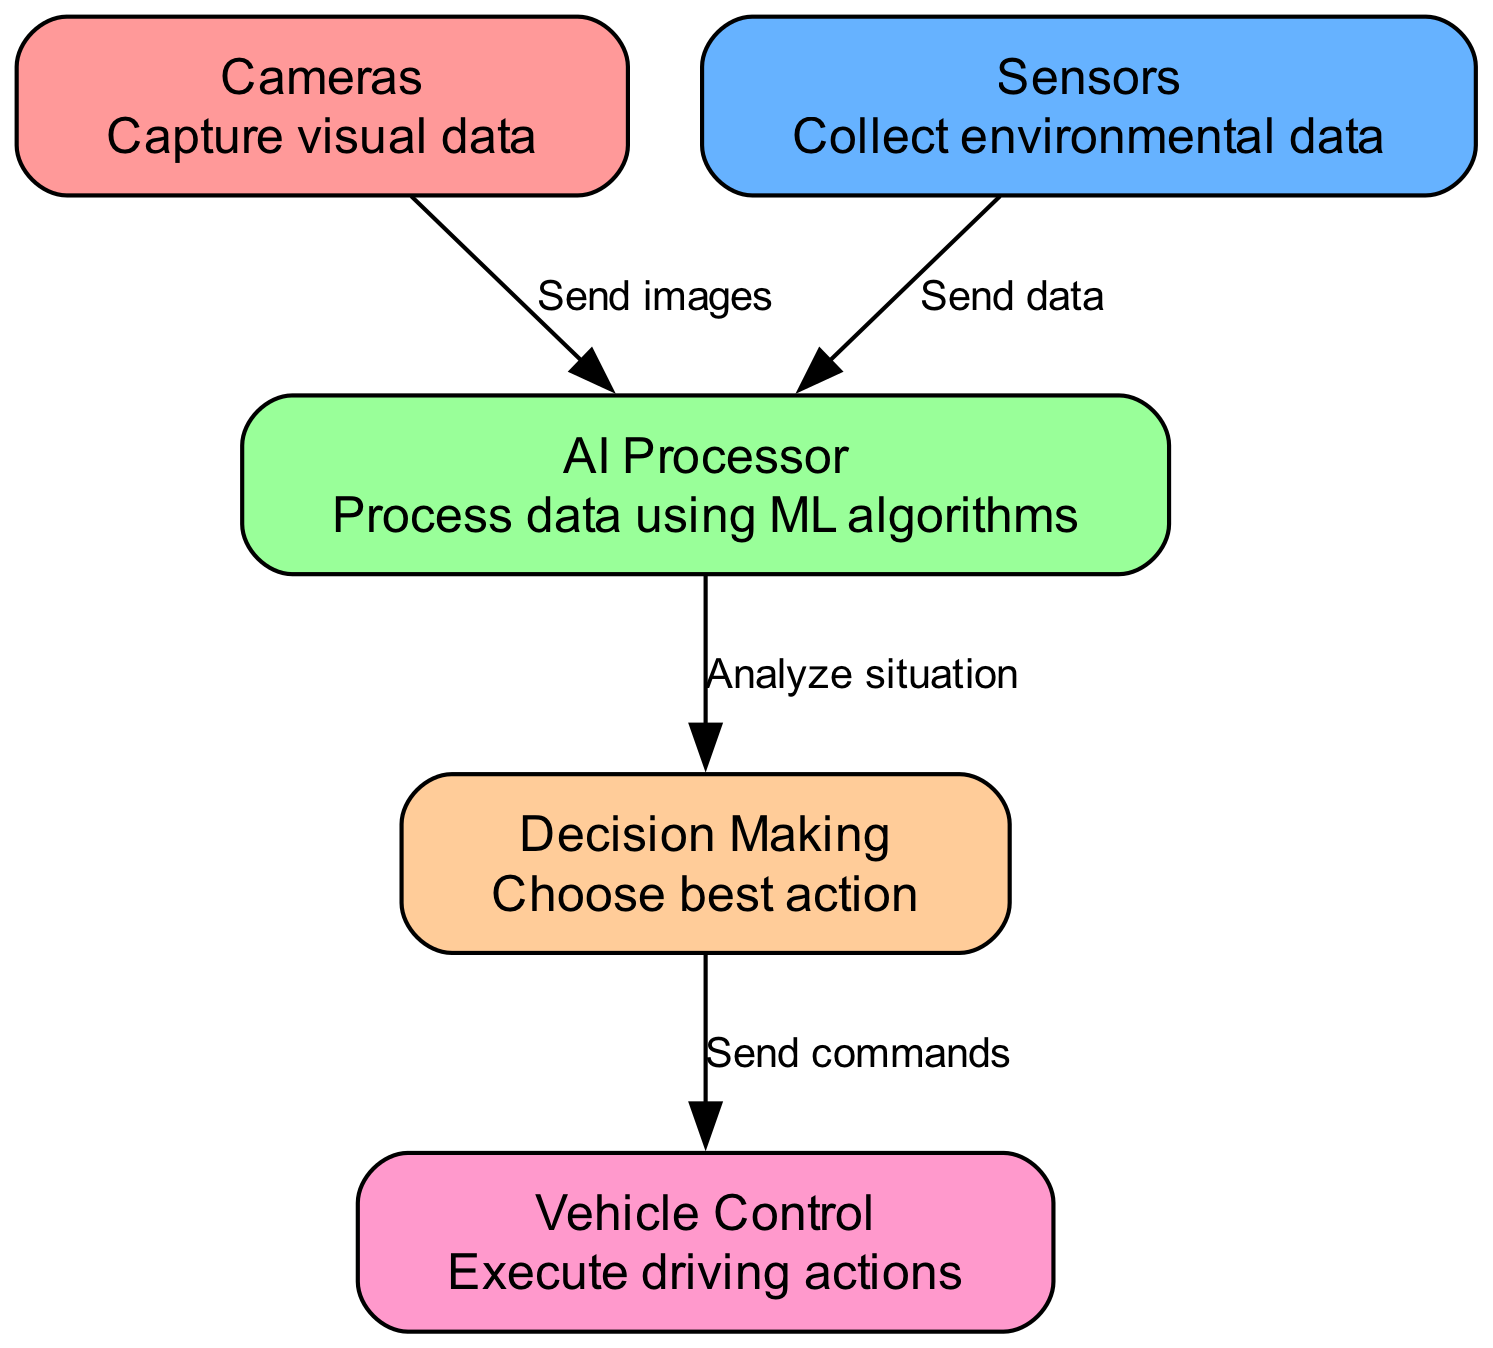What nodes are present in the diagram? The diagram contains five nodes: Cameras, Sensors, AI Processor, Decision Making, and Vehicle Control. Each node can be identified based on its unique ID and descriptive name.
Answer: Cameras, Sensors, AI Processor, Decision Making, Vehicle Control What is the function of the AI Processor? In the diagram, the AI Processor is described as the component that processes data using machine learning algorithms. It plays a critical role in analyzing the information received from other nodes.
Answer: Process data using ML algorithms How many edges are there in total? The diagram shows four edges connecting the various nodes, indicating the flow of information between them. Each relationship in the diagram is characterized by a directed edge.
Answer: Four What do the Cameras send to the AI Processor? The Cameras in the diagram send images to the AI Processor. This action establishes the first step in the decision-making process for the self-driving car.
Answer: Send images What is the final action that the diagram illustrates? The final action illustrated in the diagram is executed by the Vehicle Control. After decisions are made, this component carries out the driving actions as determined by the prior processes.
Answer: Execute driving actions What does the Decision Making node do with the analyzed situation? The Decision Making node chooses the best action based on the analysis of the situation conducted by the AI Processor. It is a critical step where the most appropriate driving commands are determined.
Answer: Choose best action How do Sensors contribute to the process? Sensors collect environmental data and send it to the AI Processor, which helps in the comprehensive analysis needed for the self-driving car to make informed decisions.
Answer: Send data What is the relationship between Decision Making and Vehicle Control? The Decision Making node sends commands to the Vehicle Control, indicating a direct relationship where decisions lead to specific driving actions being executed.
Answer: Send commands 